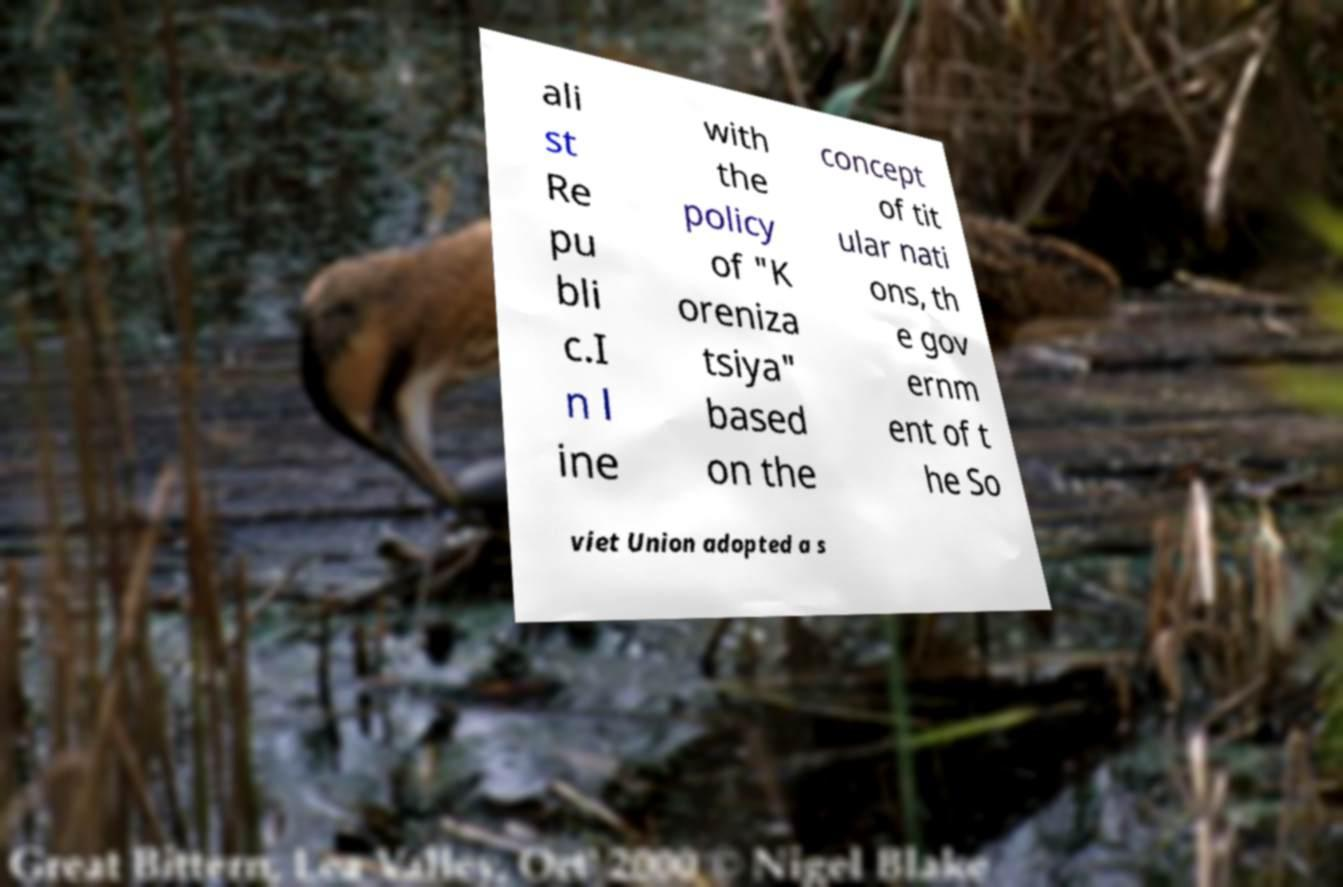Please identify and transcribe the text found in this image. ali st Re pu bli c.I n l ine with the policy of "K oreniza tsiya" based on the concept of tit ular nati ons, th e gov ernm ent of t he So viet Union adopted a s 